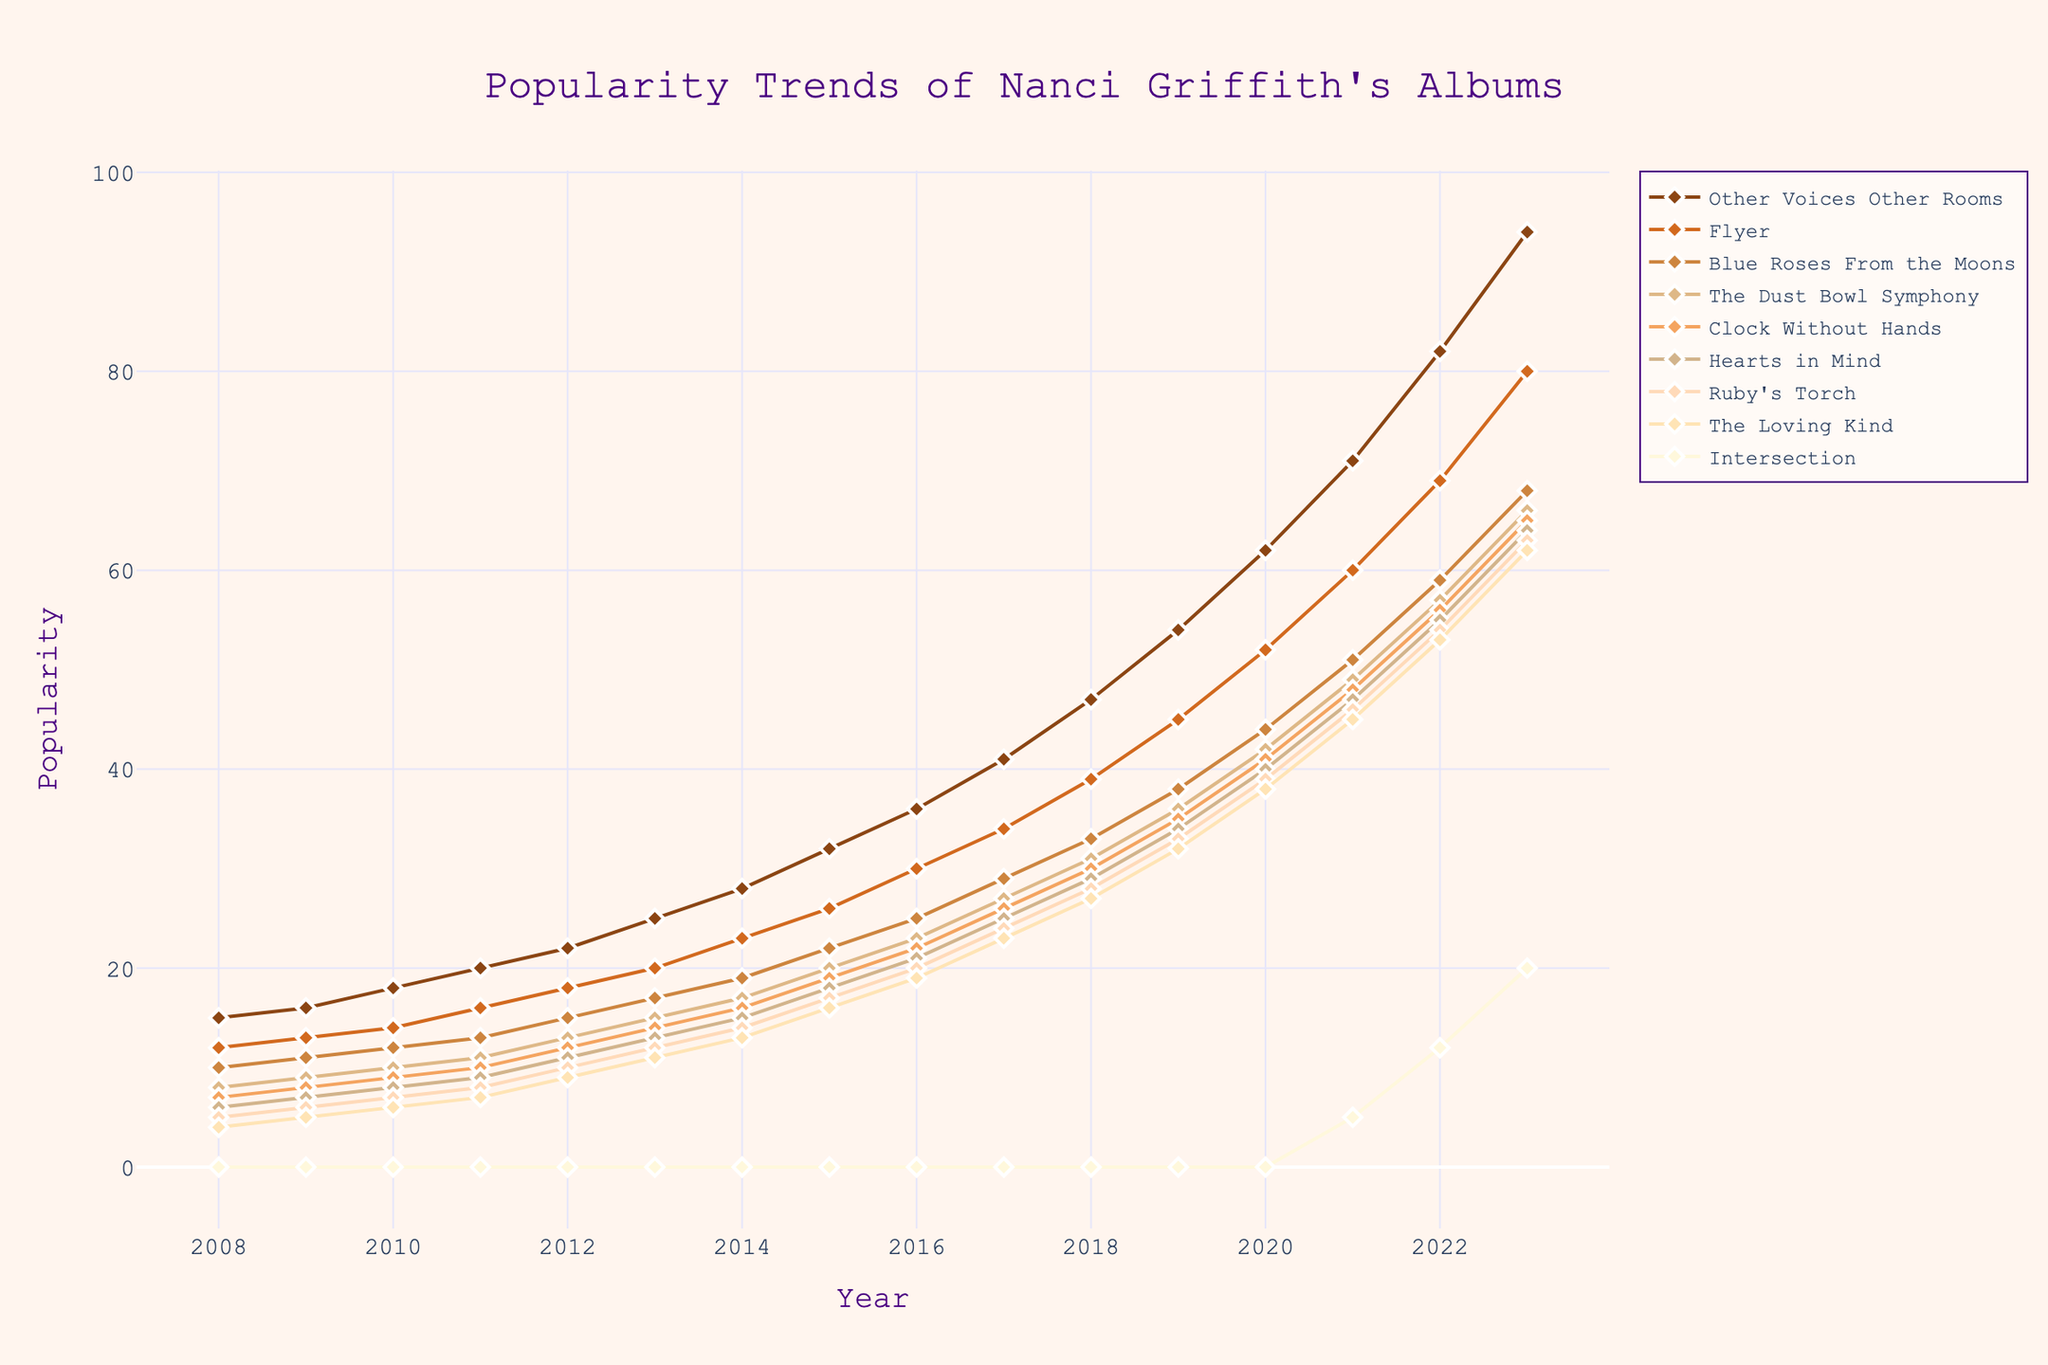What is the trend of popularity for the album "Other Voices Other Rooms" from 2008 to 2023? To find the trend, observe the line representing "Other Voices Other Rooms." This line starts at a value of 15 in 2008 and rises continuously each year to reach 94 by 2023. The trend is clearly upward.
Answer: Upward trend How does the popularity of "The Loving Kind" change from 2010 to 2021? Review the values in the line chart for "The Loving Kind" between 2010 and 2021. The values start at 6 in 2010 and increase steadily to 45 by 2021. This shows that the popularity consistently increased.
Answer: Consistently increased Which album showed the greatest increase in popularity from 2008 to 2023? Compare the starting and ending values for each album. "Other Voices Other Rooms" increased the most from 15 in 2008 to 94 in 2023, a difference of 79.
Answer: "Other Voices Other Rooms" In which year did the album "Intersection" first appear in the popularity trend? Look for the first year with a positive value for the "Intersection" line. It first appears with a value of 5 in 2021.
Answer: 2021 Between "Flyer" and "Clock Without Hands," which had higher popularity in 2013? Check the values for the two albums in 2013. "Flyer" is at 20 and "Clock Without Hands" is at 14. Therefore, "Flyer" had higher popularity.
Answer: "Flyer" What is the average popularity of "Blue Roses From the Moons" from 2008 to 2023? Add the values from 2008 to 2023 (10, 11, 12, 13, 15, 17, 19, 22, 25, 29, 33, 38, 44, 51, 59, 68) and divide by the number of values (16). The sum is 376, and the average is 376/16 = 23.5.
Answer: 23.5 Compare the slope of the trend lines for "The Dust Bowl Symphony" and "Hearts in Mind." Which trend is steeper? The slope is determined by how quickly the popularity values rise over time. "The Dust Bowl Symphony" rises from 8 to 66 (difference of 58) while "Hearts in Mind" rises from 6 to 64 (difference of 58) between 2008 and 2023. Despite both having the same difference, "Hearts in Mind" had a smaller initial value, making its relative increase larger, hence steeper.
Answer: "Hearts in Mind" How does the color coding differentiate the albums on the chart? Each album is represented by a unique color in the provided color palette, from shades of brown to lighter colors like peach. This helps distinguish the lines visually on the chart.
Answer: Unique color for each album Which album had zero popularity in the most years displayed? "Intersection" has zero popularity from 2008 to 2020, which is a total of 13 years. The next step is to verify that none of the other albums have zeros in more years.
Answer: "Intersection" 